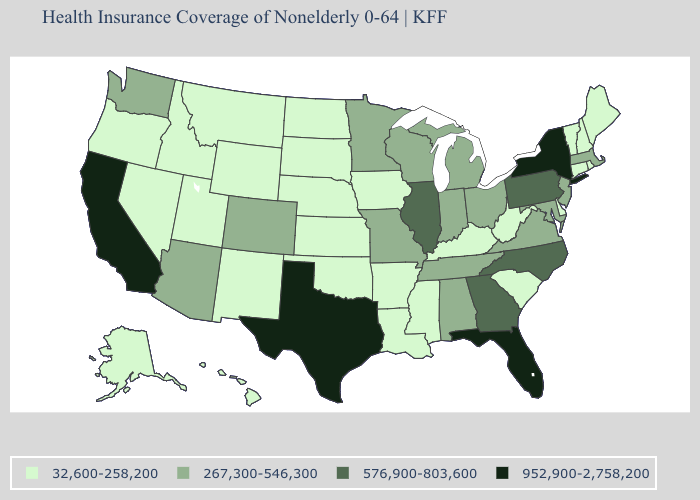Name the states that have a value in the range 952,900-2,758,200?
Quick response, please. California, Florida, New York, Texas. Which states have the highest value in the USA?
Quick response, please. California, Florida, New York, Texas. How many symbols are there in the legend?
Quick response, please. 4. What is the value of California?
Be succinct. 952,900-2,758,200. Which states have the lowest value in the Northeast?
Write a very short answer. Connecticut, Maine, New Hampshire, Rhode Island, Vermont. Among the states that border Maryland , which have the highest value?
Short answer required. Pennsylvania. Is the legend a continuous bar?
Give a very brief answer. No. What is the highest value in the Northeast ?
Short answer required. 952,900-2,758,200. Among the states that border Iowa , which have the highest value?
Answer briefly. Illinois. What is the lowest value in the USA?
Keep it brief. 32,600-258,200. How many symbols are there in the legend?
Quick response, please. 4. What is the value of Washington?
Write a very short answer. 267,300-546,300. Does the map have missing data?
Quick response, please. No. What is the value of North Dakota?
Concise answer only. 32,600-258,200. 